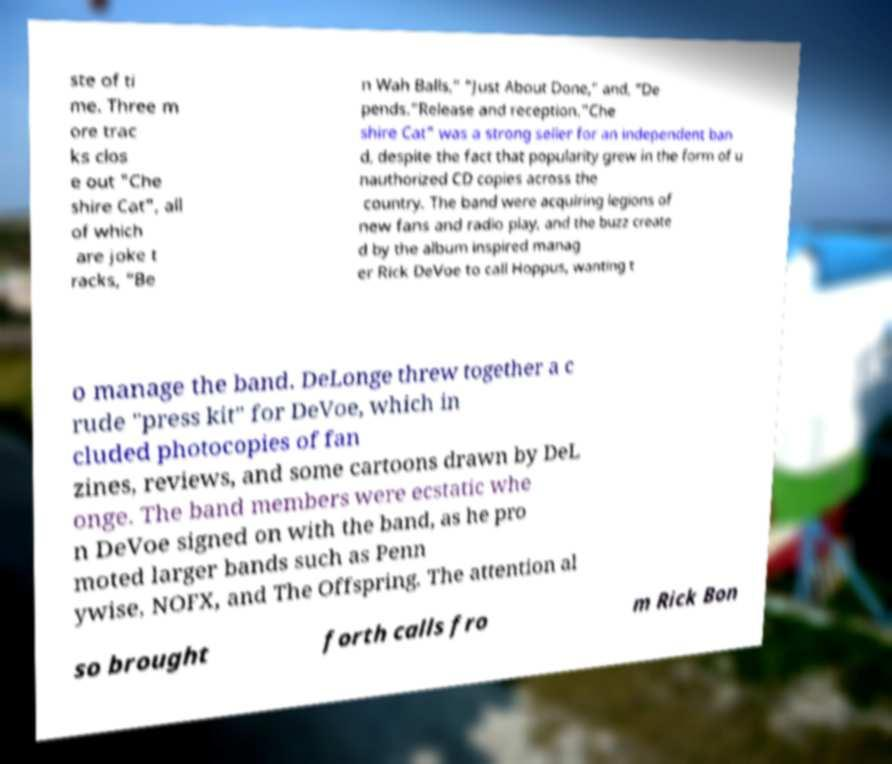What messages or text are displayed in this image? I need them in a readable, typed format. ste of ti me. Three m ore trac ks clos e out "Che shire Cat", all of which are joke t racks, “Be n Wah Balls,” “Just About Done,” and, “De pends.”Release and reception."Che shire Cat" was a strong seller for an independent ban d, despite the fact that popularity grew in the form of u nauthorized CD copies across the country. The band were acquiring legions of new fans and radio play, and the buzz create d by the album inspired manag er Rick DeVoe to call Hoppus, wanting t o manage the band. DeLonge threw together a c rude "press kit" for DeVoe, which in cluded photocopies of fan zines, reviews, and some cartoons drawn by DeL onge. The band members were ecstatic whe n DeVoe signed on with the band, as he pro moted larger bands such as Penn ywise, NOFX, and The Offspring. The attention al so brought forth calls fro m Rick Bon 